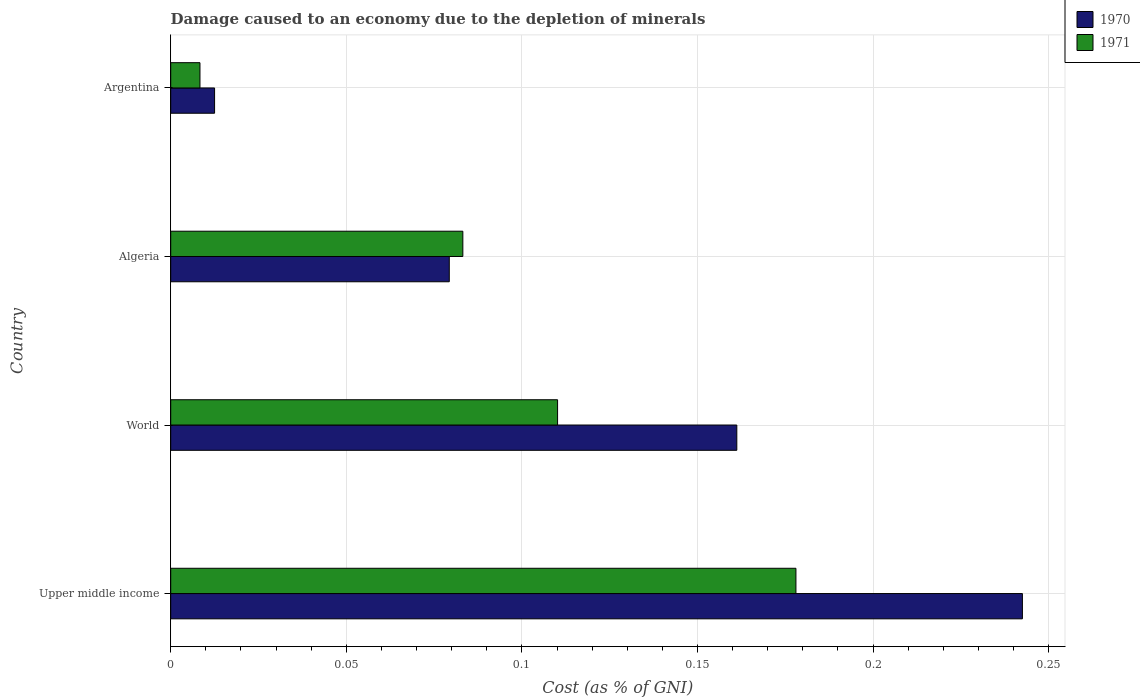How many different coloured bars are there?
Provide a succinct answer. 2. How many groups of bars are there?
Provide a succinct answer. 4. How many bars are there on the 4th tick from the bottom?
Give a very brief answer. 2. What is the label of the 3rd group of bars from the top?
Make the answer very short. World. What is the cost of damage caused due to the depletion of minerals in 1970 in Argentina?
Your answer should be very brief. 0.01. Across all countries, what is the maximum cost of damage caused due to the depletion of minerals in 1970?
Offer a terse response. 0.24. Across all countries, what is the minimum cost of damage caused due to the depletion of minerals in 1970?
Make the answer very short. 0.01. In which country was the cost of damage caused due to the depletion of minerals in 1970 maximum?
Offer a terse response. Upper middle income. What is the total cost of damage caused due to the depletion of minerals in 1970 in the graph?
Offer a very short reply. 0.5. What is the difference between the cost of damage caused due to the depletion of minerals in 1971 in Upper middle income and that in World?
Provide a short and direct response. 0.07. What is the difference between the cost of damage caused due to the depletion of minerals in 1971 in Argentina and the cost of damage caused due to the depletion of minerals in 1970 in World?
Your answer should be very brief. -0.15. What is the average cost of damage caused due to the depletion of minerals in 1971 per country?
Keep it short and to the point. 0.09. What is the difference between the cost of damage caused due to the depletion of minerals in 1970 and cost of damage caused due to the depletion of minerals in 1971 in World?
Keep it short and to the point. 0.05. In how many countries, is the cost of damage caused due to the depletion of minerals in 1971 greater than 0.23 %?
Give a very brief answer. 0. What is the ratio of the cost of damage caused due to the depletion of minerals in 1971 in Upper middle income to that in World?
Provide a succinct answer. 1.62. Is the cost of damage caused due to the depletion of minerals in 1971 in Argentina less than that in World?
Give a very brief answer. Yes. What is the difference between the highest and the second highest cost of damage caused due to the depletion of minerals in 1971?
Your answer should be very brief. 0.07. What is the difference between the highest and the lowest cost of damage caused due to the depletion of minerals in 1971?
Provide a succinct answer. 0.17. In how many countries, is the cost of damage caused due to the depletion of minerals in 1971 greater than the average cost of damage caused due to the depletion of minerals in 1971 taken over all countries?
Give a very brief answer. 2. Is the sum of the cost of damage caused due to the depletion of minerals in 1970 in Algeria and Upper middle income greater than the maximum cost of damage caused due to the depletion of minerals in 1971 across all countries?
Your answer should be very brief. Yes. How many countries are there in the graph?
Provide a short and direct response. 4. What is the difference between two consecutive major ticks on the X-axis?
Provide a short and direct response. 0.05. Does the graph contain any zero values?
Your answer should be very brief. No. Does the graph contain grids?
Your answer should be very brief. Yes. How are the legend labels stacked?
Keep it short and to the point. Vertical. What is the title of the graph?
Provide a short and direct response. Damage caused to an economy due to the depletion of minerals. Does "1988" appear as one of the legend labels in the graph?
Offer a terse response. No. What is the label or title of the X-axis?
Offer a very short reply. Cost (as % of GNI). What is the label or title of the Y-axis?
Give a very brief answer. Country. What is the Cost (as % of GNI) of 1970 in Upper middle income?
Provide a short and direct response. 0.24. What is the Cost (as % of GNI) in 1971 in Upper middle income?
Your answer should be compact. 0.18. What is the Cost (as % of GNI) in 1970 in World?
Offer a terse response. 0.16. What is the Cost (as % of GNI) of 1971 in World?
Provide a succinct answer. 0.11. What is the Cost (as % of GNI) of 1970 in Algeria?
Your answer should be very brief. 0.08. What is the Cost (as % of GNI) of 1971 in Algeria?
Keep it short and to the point. 0.08. What is the Cost (as % of GNI) in 1970 in Argentina?
Offer a terse response. 0.01. What is the Cost (as % of GNI) of 1971 in Argentina?
Your response must be concise. 0.01. Across all countries, what is the maximum Cost (as % of GNI) of 1970?
Give a very brief answer. 0.24. Across all countries, what is the maximum Cost (as % of GNI) of 1971?
Give a very brief answer. 0.18. Across all countries, what is the minimum Cost (as % of GNI) of 1970?
Provide a short and direct response. 0.01. Across all countries, what is the minimum Cost (as % of GNI) of 1971?
Keep it short and to the point. 0.01. What is the total Cost (as % of GNI) of 1970 in the graph?
Offer a terse response. 0.5. What is the total Cost (as % of GNI) of 1971 in the graph?
Offer a very short reply. 0.38. What is the difference between the Cost (as % of GNI) in 1970 in Upper middle income and that in World?
Your response must be concise. 0.08. What is the difference between the Cost (as % of GNI) of 1971 in Upper middle income and that in World?
Keep it short and to the point. 0.07. What is the difference between the Cost (as % of GNI) of 1970 in Upper middle income and that in Algeria?
Provide a succinct answer. 0.16. What is the difference between the Cost (as % of GNI) of 1971 in Upper middle income and that in Algeria?
Ensure brevity in your answer.  0.09. What is the difference between the Cost (as % of GNI) in 1970 in Upper middle income and that in Argentina?
Give a very brief answer. 0.23. What is the difference between the Cost (as % of GNI) in 1971 in Upper middle income and that in Argentina?
Ensure brevity in your answer.  0.17. What is the difference between the Cost (as % of GNI) of 1970 in World and that in Algeria?
Your response must be concise. 0.08. What is the difference between the Cost (as % of GNI) in 1971 in World and that in Algeria?
Provide a short and direct response. 0.03. What is the difference between the Cost (as % of GNI) in 1970 in World and that in Argentina?
Give a very brief answer. 0.15. What is the difference between the Cost (as % of GNI) of 1971 in World and that in Argentina?
Keep it short and to the point. 0.1. What is the difference between the Cost (as % of GNI) in 1970 in Algeria and that in Argentina?
Make the answer very short. 0.07. What is the difference between the Cost (as % of GNI) in 1971 in Algeria and that in Argentina?
Your response must be concise. 0.07. What is the difference between the Cost (as % of GNI) of 1970 in Upper middle income and the Cost (as % of GNI) of 1971 in World?
Keep it short and to the point. 0.13. What is the difference between the Cost (as % of GNI) of 1970 in Upper middle income and the Cost (as % of GNI) of 1971 in Algeria?
Your response must be concise. 0.16. What is the difference between the Cost (as % of GNI) of 1970 in Upper middle income and the Cost (as % of GNI) of 1971 in Argentina?
Your answer should be very brief. 0.23. What is the difference between the Cost (as % of GNI) in 1970 in World and the Cost (as % of GNI) in 1971 in Algeria?
Your answer should be compact. 0.08. What is the difference between the Cost (as % of GNI) in 1970 in World and the Cost (as % of GNI) in 1971 in Argentina?
Your answer should be very brief. 0.15. What is the difference between the Cost (as % of GNI) in 1970 in Algeria and the Cost (as % of GNI) in 1971 in Argentina?
Offer a terse response. 0.07. What is the average Cost (as % of GNI) of 1970 per country?
Make the answer very short. 0.12. What is the average Cost (as % of GNI) in 1971 per country?
Your answer should be compact. 0.09. What is the difference between the Cost (as % of GNI) in 1970 and Cost (as % of GNI) in 1971 in Upper middle income?
Provide a succinct answer. 0.06. What is the difference between the Cost (as % of GNI) in 1970 and Cost (as % of GNI) in 1971 in World?
Ensure brevity in your answer.  0.05. What is the difference between the Cost (as % of GNI) of 1970 and Cost (as % of GNI) of 1971 in Algeria?
Ensure brevity in your answer.  -0. What is the difference between the Cost (as % of GNI) of 1970 and Cost (as % of GNI) of 1971 in Argentina?
Offer a very short reply. 0. What is the ratio of the Cost (as % of GNI) of 1970 in Upper middle income to that in World?
Give a very brief answer. 1.5. What is the ratio of the Cost (as % of GNI) in 1971 in Upper middle income to that in World?
Ensure brevity in your answer.  1.62. What is the ratio of the Cost (as % of GNI) of 1970 in Upper middle income to that in Algeria?
Offer a terse response. 3.06. What is the ratio of the Cost (as % of GNI) in 1971 in Upper middle income to that in Algeria?
Make the answer very short. 2.14. What is the ratio of the Cost (as % of GNI) in 1970 in Upper middle income to that in Argentina?
Give a very brief answer. 19.42. What is the ratio of the Cost (as % of GNI) in 1971 in Upper middle income to that in Argentina?
Provide a succinct answer. 21.37. What is the ratio of the Cost (as % of GNI) in 1970 in World to that in Algeria?
Give a very brief answer. 2.03. What is the ratio of the Cost (as % of GNI) in 1971 in World to that in Algeria?
Provide a succinct answer. 1.32. What is the ratio of the Cost (as % of GNI) in 1970 in World to that in Argentina?
Provide a short and direct response. 12.9. What is the ratio of the Cost (as % of GNI) in 1971 in World to that in Argentina?
Provide a short and direct response. 13.22. What is the ratio of the Cost (as % of GNI) in 1970 in Algeria to that in Argentina?
Give a very brief answer. 6.35. What is the ratio of the Cost (as % of GNI) of 1971 in Algeria to that in Argentina?
Provide a succinct answer. 9.99. What is the difference between the highest and the second highest Cost (as % of GNI) of 1970?
Offer a terse response. 0.08. What is the difference between the highest and the second highest Cost (as % of GNI) of 1971?
Make the answer very short. 0.07. What is the difference between the highest and the lowest Cost (as % of GNI) in 1970?
Keep it short and to the point. 0.23. What is the difference between the highest and the lowest Cost (as % of GNI) of 1971?
Make the answer very short. 0.17. 